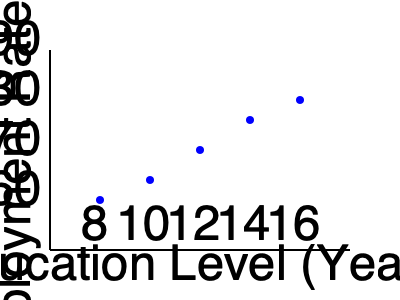Based on the scatter plot showing the relationship between education levels and employment rates among Jewish immigrants, what type of correlation can be observed, and how might this information be useful in your work as a social worker? To answer this question, let's analyze the scatter plot step-by-step:

1. Observe the data points: The plot shows five data points representing different education levels and corresponding employment rates.

2. Identify the trend: As we move from left to right (increasing education levels), the data points tend to move upwards (increasing employment rates).

3. Determine the correlation type: This upward trend indicates a positive correlation between education levels and employment rates.

4. Assess the strength: The points follow a relatively consistent upward pattern, suggesting a strong positive correlation.

5. Calculate the correlation: While we can't calculate an exact correlation coefficient without the raw data, visually, it appears to be a strong positive correlation, potentially around 0.8 to 0.9.

6. Interpret the results: This correlation suggests that Jewish immigrants with higher education levels tend to have higher employment rates.

7. Apply to social work: As a social worker, this information can be valuable in several ways:
   a. Emphasize the importance of education in improving employment prospects for immigrants.
   b. Develop programs to support further education or skill development for immigrants.
   c. Target additional support to immigrants with lower education levels who may struggle more with employment.
   d. Use this data to advocate for educational resources and opportunities for immigrant communities.

8. Consider limitations: Remember that correlation does not imply causation, and other factors may influence employment rates.
Answer: Strong positive correlation; useful for developing targeted education and employment support programs for immigrants. 